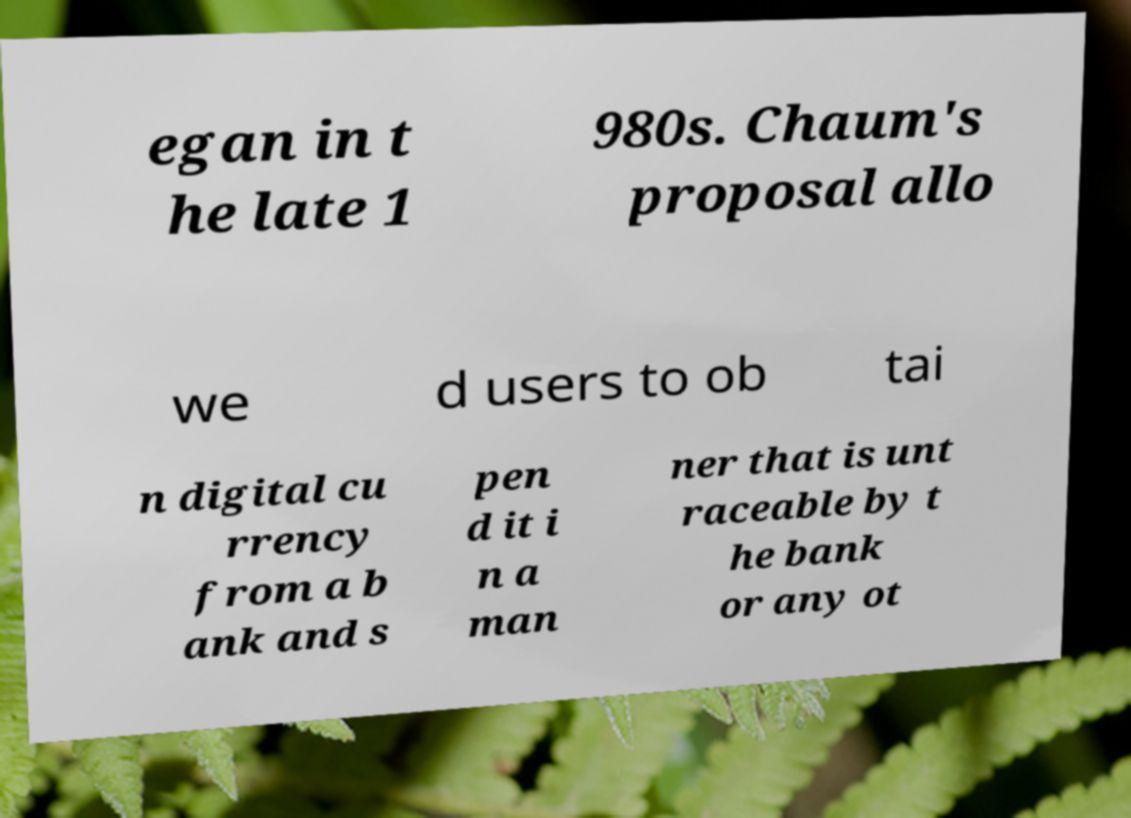Can you read and provide the text displayed in the image?This photo seems to have some interesting text. Can you extract and type it out for me? egan in t he late 1 980s. Chaum's proposal allo we d users to ob tai n digital cu rrency from a b ank and s pen d it i n a man ner that is unt raceable by t he bank or any ot 